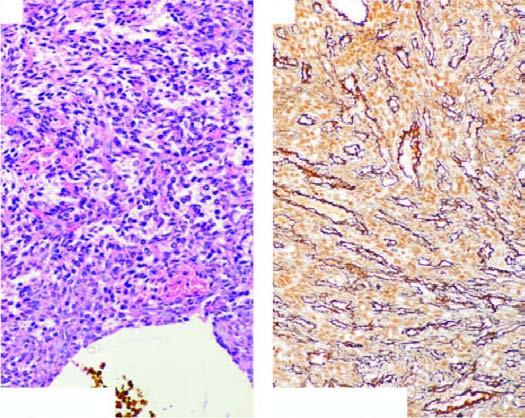what do cells surround?
Answer the question using a single word or phrase. Vascular lumina in a whorled fashion 